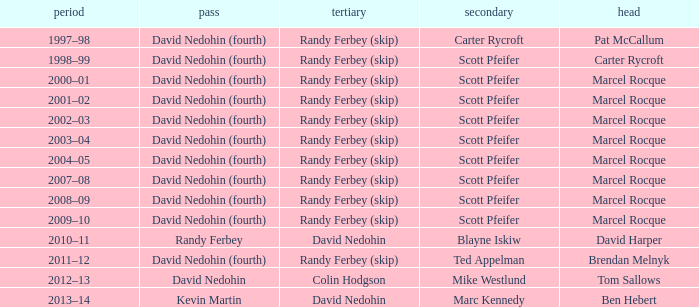Can you give me this table as a dict? {'header': ['period', 'pass', 'tertiary', 'secondary', 'head'], 'rows': [['1997–98', 'David Nedohin (fourth)', 'Randy Ferbey (skip)', 'Carter Rycroft', 'Pat McCallum'], ['1998–99', 'David Nedohin (fourth)', 'Randy Ferbey (skip)', 'Scott Pfeifer', 'Carter Rycroft'], ['2000–01', 'David Nedohin (fourth)', 'Randy Ferbey (skip)', 'Scott Pfeifer', 'Marcel Rocque'], ['2001–02', 'David Nedohin (fourth)', 'Randy Ferbey (skip)', 'Scott Pfeifer', 'Marcel Rocque'], ['2002–03', 'David Nedohin (fourth)', 'Randy Ferbey (skip)', 'Scott Pfeifer', 'Marcel Rocque'], ['2003–04', 'David Nedohin (fourth)', 'Randy Ferbey (skip)', 'Scott Pfeifer', 'Marcel Rocque'], ['2004–05', 'David Nedohin (fourth)', 'Randy Ferbey (skip)', 'Scott Pfeifer', 'Marcel Rocque'], ['2007–08', 'David Nedohin (fourth)', 'Randy Ferbey (skip)', 'Scott Pfeifer', 'Marcel Rocque'], ['2008–09', 'David Nedohin (fourth)', 'Randy Ferbey (skip)', 'Scott Pfeifer', 'Marcel Rocque'], ['2009–10', 'David Nedohin (fourth)', 'Randy Ferbey (skip)', 'Scott Pfeifer', 'Marcel Rocque'], ['2010–11', 'Randy Ferbey', 'David Nedohin', 'Blayne Iskiw', 'David Harper'], ['2011–12', 'David Nedohin (fourth)', 'Randy Ferbey (skip)', 'Ted Appelman', 'Brendan Melnyk'], ['2012–13', 'David Nedohin', 'Colin Hodgson', 'Mike Westlund', 'Tom Sallows'], ['2013–14', 'Kevin Martin', 'David Nedohin', 'Marc Kennedy', 'Ben Hebert']]} Which Season has a Third of colin hodgson? 2012–13. 